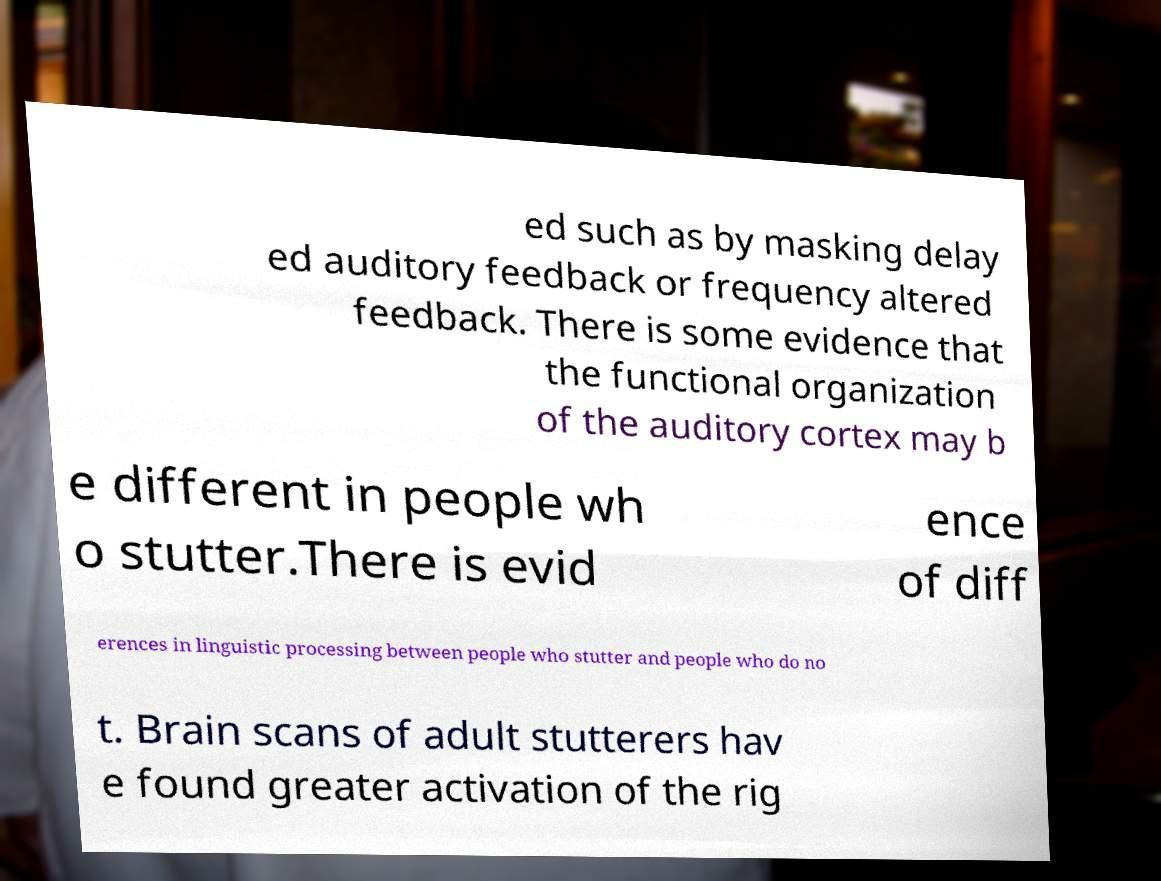Could you extract and type out the text from this image? ed such as by masking delay ed auditory feedback or frequency altered feedback. There is some evidence that the functional organization of the auditory cortex may b e different in people wh o stutter.There is evid ence of diff erences in linguistic processing between people who stutter and people who do no t. Brain scans of adult stutterers hav e found greater activation of the rig 